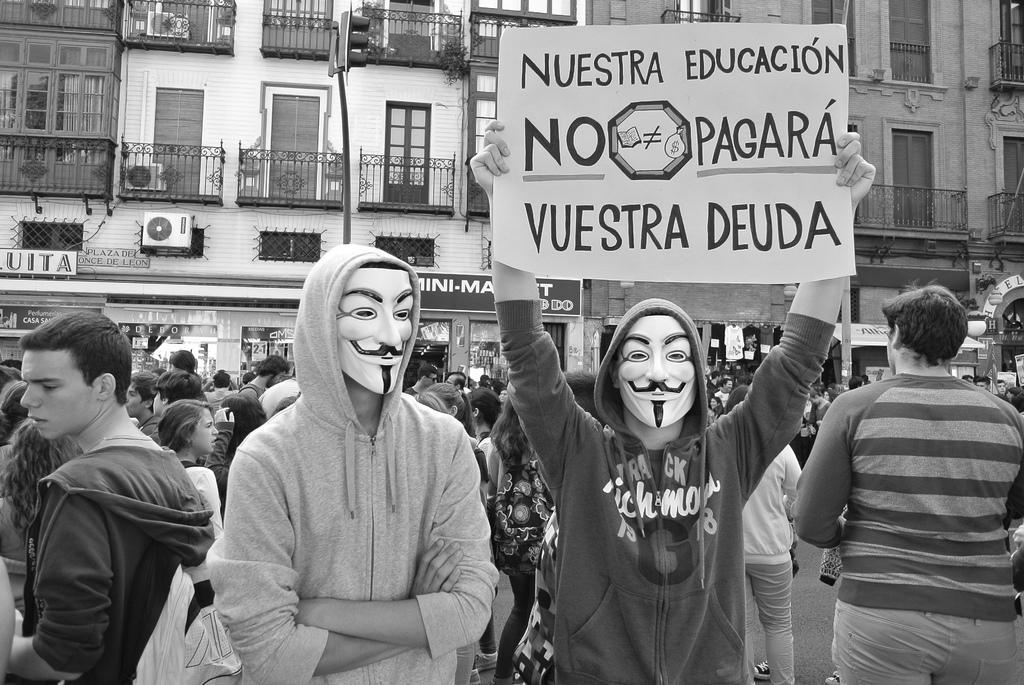Could you give a brief overview of what you see in this image? In the foreground I can see a crowd on the road, posters and few of them are wearing mask on their faces. In the background I can see buildings, shops, windows and so on. This image is taken may be during a day. 